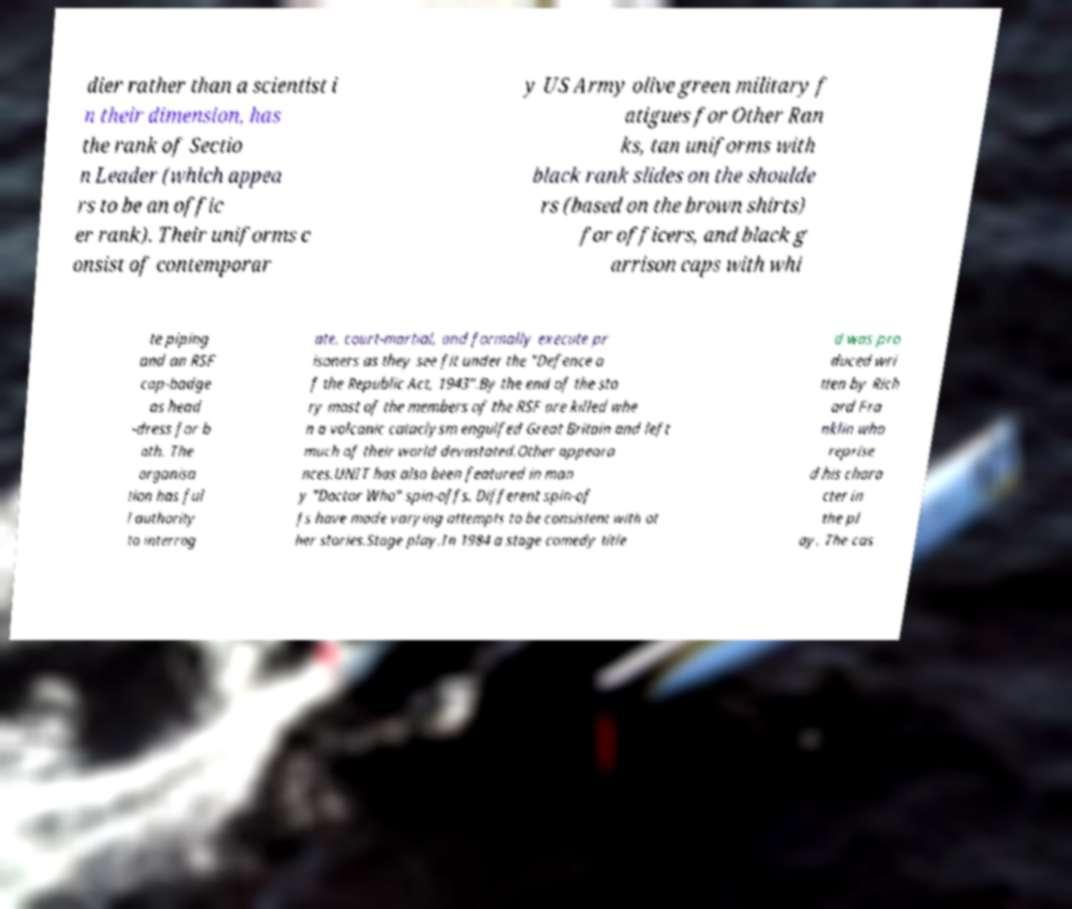Please read and relay the text visible in this image. What does it say? dier rather than a scientist i n their dimension, has the rank of Sectio n Leader (which appea rs to be an offic er rank). Their uniforms c onsist of contemporar y US Army olive green military f atigues for Other Ran ks, tan uniforms with black rank slides on the shoulde rs (based on the brown shirts) for officers, and black g arrison caps with whi te piping and an RSF cap-badge as head -dress for b oth. The organisa tion has ful l authority to interrog ate, court-martial, and formally execute pr isoners as they see fit under the "Defence o f the Republic Act, 1943".By the end of the sto ry most of the members of the RSF are killed whe n a volcanic cataclysm engulfed Great Britain and left much of their world devastated.Other appeara nces.UNIT has also been featured in man y "Doctor Who" spin-offs. Different spin-of fs have made varying attempts to be consistent with ot her stories.Stage play.In 1984 a stage comedy title d was pro duced wri tten by Rich ard Fra nklin who reprise d his chara cter in the pl ay. The cas 